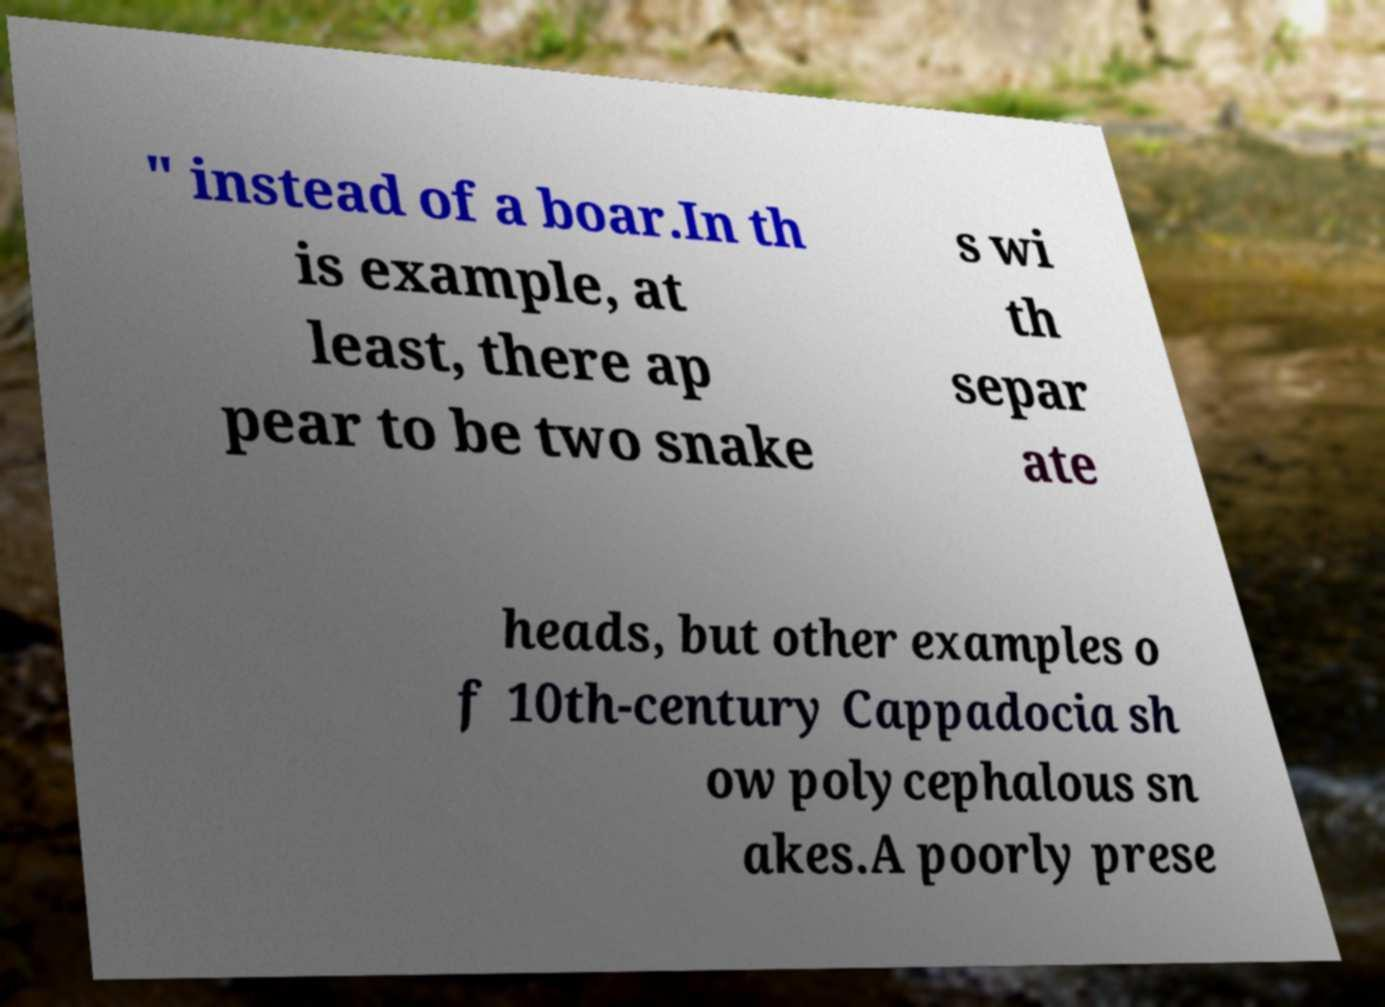There's text embedded in this image that I need extracted. Can you transcribe it verbatim? " instead of a boar.In th is example, at least, there ap pear to be two snake s wi th separ ate heads, but other examples o f 10th-century Cappadocia sh ow polycephalous sn akes.A poorly prese 